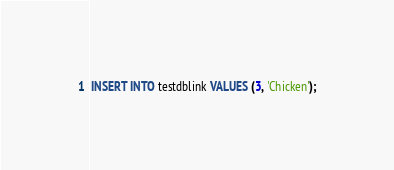Convert code to text. <code><loc_0><loc_0><loc_500><loc_500><_SQL_>
INSERT INTO testdblink VALUES (3, 'Chicken');
</code> 